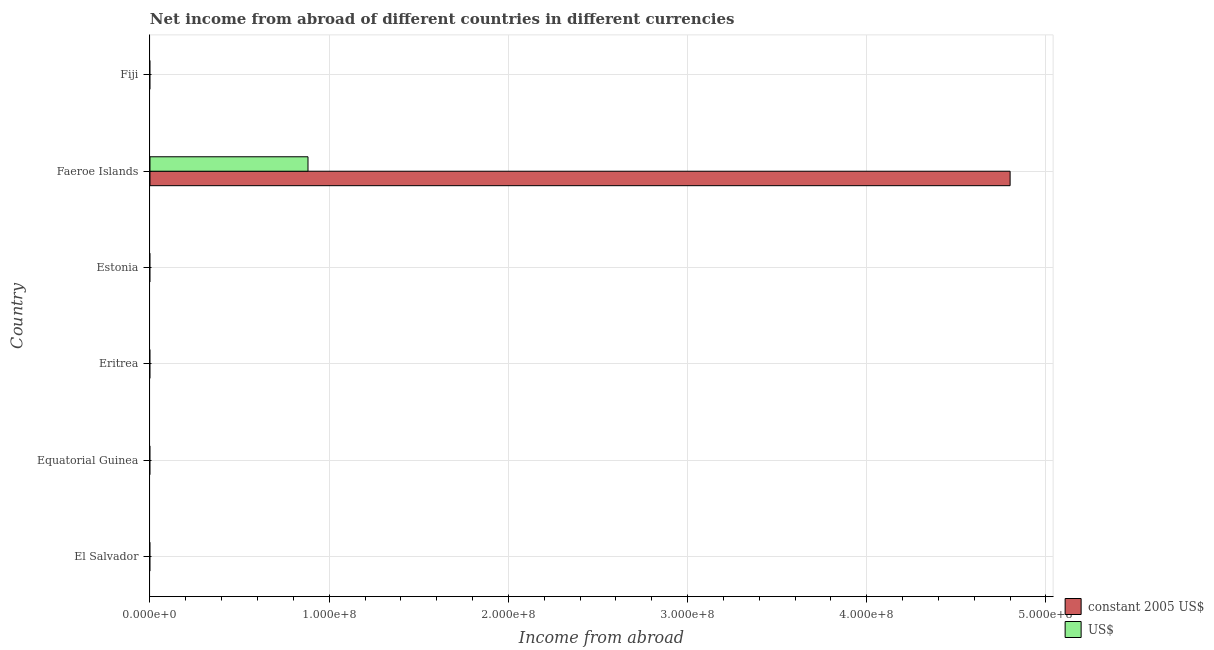How many different coloured bars are there?
Provide a succinct answer. 2. Are the number of bars on each tick of the Y-axis equal?
Offer a terse response. No. How many bars are there on the 6th tick from the top?
Offer a very short reply. 0. What is the label of the 4th group of bars from the top?
Give a very brief answer. Eritrea. In how many cases, is the number of bars for a given country not equal to the number of legend labels?
Ensure brevity in your answer.  5. Across all countries, what is the maximum income from abroad in us$?
Make the answer very short. 8.82e+07. In which country was the income from abroad in us$ maximum?
Offer a very short reply. Faeroe Islands. What is the total income from abroad in us$ in the graph?
Keep it short and to the point. 8.82e+07. What is the difference between the income from abroad in constant 2005 us$ in Estonia and the income from abroad in us$ in Fiji?
Your response must be concise. 0. What is the average income from abroad in us$ per country?
Provide a short and direct response. 1.47e+07. What is the difference between the income from abroad in constant 2005 us$ and income from abroad in us$ in Faeroe Islands?
Ensure brevity in your answer.  3.92e+08. In how many countries, is the income from abroad in us$ greater than 400000000 units?
Give a very brief answer. 0. What is the difference between the highest and the lowest income from abroad in constant 2005 us$?
Give a very brief answer. 4.80e+08. In how many countries, is the income from abroad in constant 2005 us$ greater than the average income from abroad in constant 2005 us$ taken over all countries?
Offer a very short reply. 1. How many bars are there?
Your answer should be compact. 2. What is the difference between two consecutive major ticks on the X-axis?
Your answer should be compact. 1.00e+08. Are the values on the major ticks of X-axis written in scientific E-notation?
Your answer should be compact. Yes. Does the graph contain any zero values?
Keep it short and to the point. Yes. Does the graph contain grids?
Offer a terse response. Yes. How many legend labels are there?
Your response must be concise. 2. What is the title of the graph?
Ensure brevity in your answer.  Net income from abroad of different countries in different currencies. Does "IMF nonconcessional" appear as one of the legend labels in the graph?
Make the answer very short. No. What is the label or title of the X-axis?
Your response must be concise. Income from abroad. What is the Income from abroad of US$ in El Salvador?
Provide a succinct answer. 0. What is the Income from abroad of constant 2005 US$ in Equatorial Guinea?
Your answer should be very brief. 0. What is the Income from abroad of constant 2005 US$ in Eritrea?
Give a very brief answer. 0. What is the Income from abroad of US$ in Eritrea?
Give a very brief answer. 0. What is the Income from abroad in constant 2005 US$ in Faeroe Islands?
Ensure brevity in your answer.  4.80e+08. What is the Income from abroad in US$ in Faeroe Islands?
Your answer should be compact. 8.82e+07. What is the Income from abroad of constant 2005 US$ in Fiji?
Keep it short and to the point. 0. Across all countries, what is the maximum Income from abroad of constant 2005 US$?
Make the answer very short. 4.80e+08. Across all countries, what is the maximum Income from abroad of US$?
Your response must be concise. 8.82e+07. Across all countries, what is the minimum Income from abroad of US$?
Give a very brief answer. 0. What is the total Income from abroad of constant 2005 US$ in the graph?
Give a very brief answer. 4.80e+08. What is the total Income from abroad in US$ in the graph?
Your answer should be very brief. 8.82e+07. What is the average Income from abroad in constant 2005 US$ per country?
Your response must be concise. 8.00e+07. What is the average Income from abroad of US$ per country?
Offer a very short reply. 1.47e+07. What is the difference between the Income from abroad in constant 2005 US$ and Income from abroad in US$ in Faeroe Islands?
Your answer should be very brief. 3.92e+08. What is the difference between the highest and the lowest Income from abroad in constant 2005 US$?
Keep it short and to the point. 4.80e+08. What is the difference between the highest and the lowest Income from abroad of US$?
Offer a very short reply. 8.82e+07. 